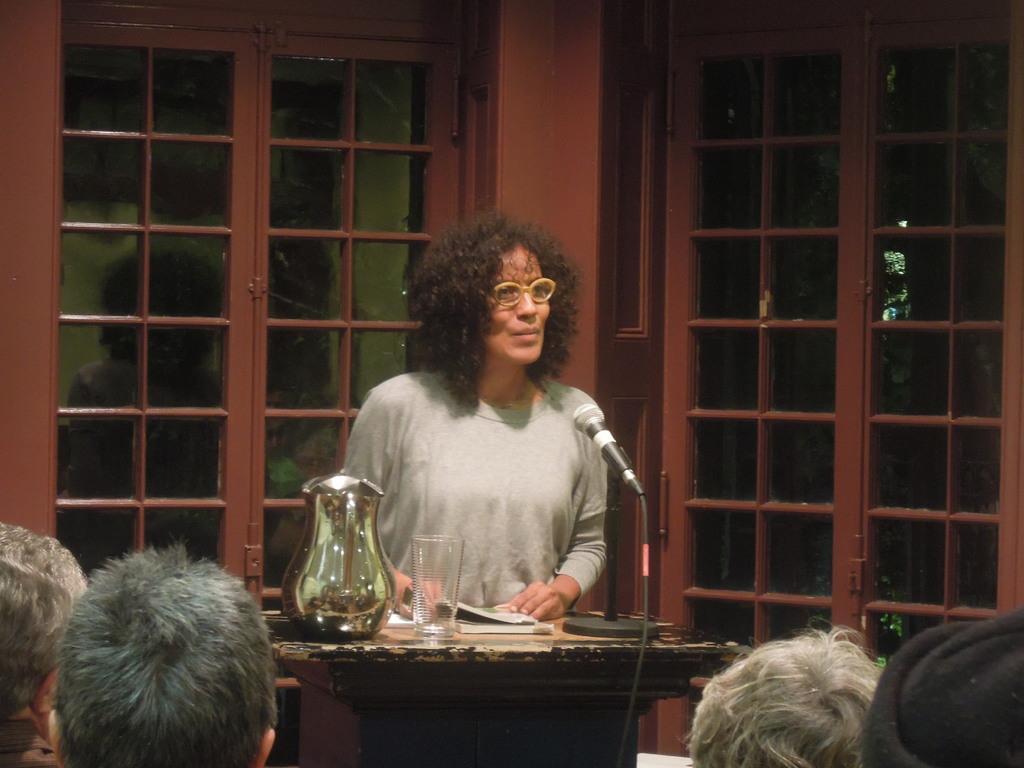Describe this image in one or two sentences. In this picture we can see some people are sitting and a man is standing behind the podium and on the podium there is a microphone with stand and a cable, book, glass and a jar. Behind the man there are doors. 